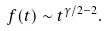Convert formula to latex. <formula><loc_0><loc_0><loc_500><loc_500>f ( t ) \sim t ^ { \gamma / 2 - 2 } .</formula> 